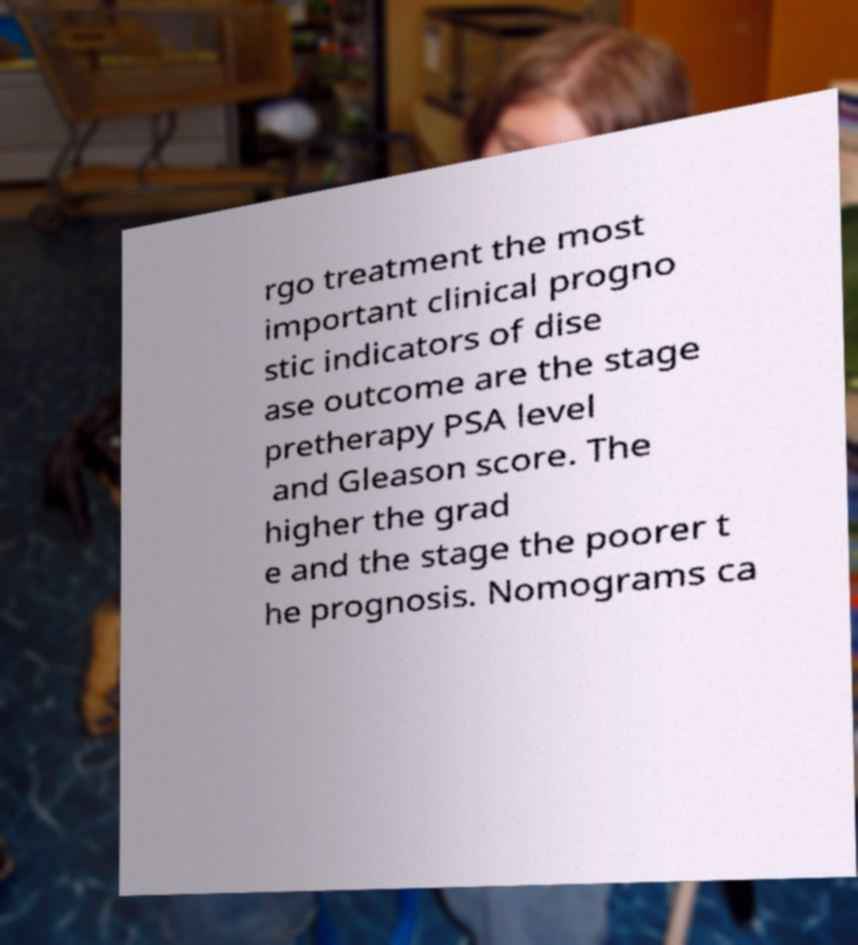Can you read and provide the text displayed in the image?This photo seems to have some interesting text. Can you extract and type it out for me? rgo treatment the most important clinical progno stic indicators of dise ase outcome are the stage pretherapy PSA level and Gleason score. The higher the grad e and the stage the poorer t he prognosis. Nomograms ca 